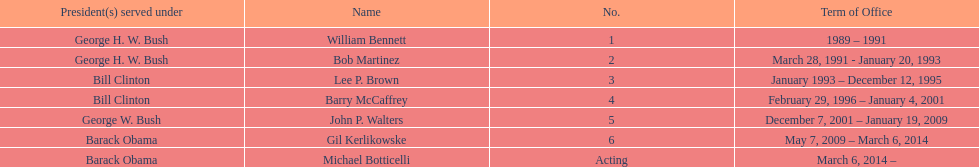What were the number of directors that stayed in office more than three years? 3. 